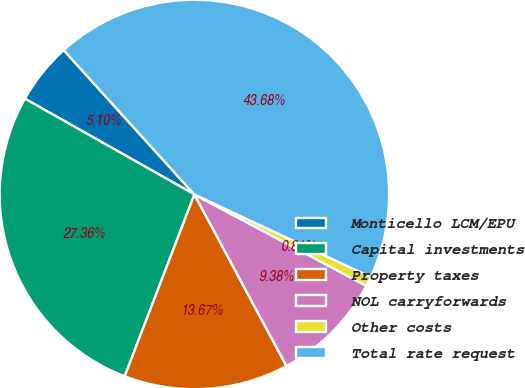Convert chart. <chart><loc_0><loc_0><loc_500><loc_500><pie_chart><fcel>Monticello LCM/EPU<fcel>Capital investments<fcel>Property taxes<fcel>NOL carryforwards<fcel>Other costs<fcel>Total rate request<nl><fcel>5.1%<fcel>27.36%<fcel>13.67%<fcel>9.38%<fcel>0.81%<fcel>43.68%<nl></chart> 